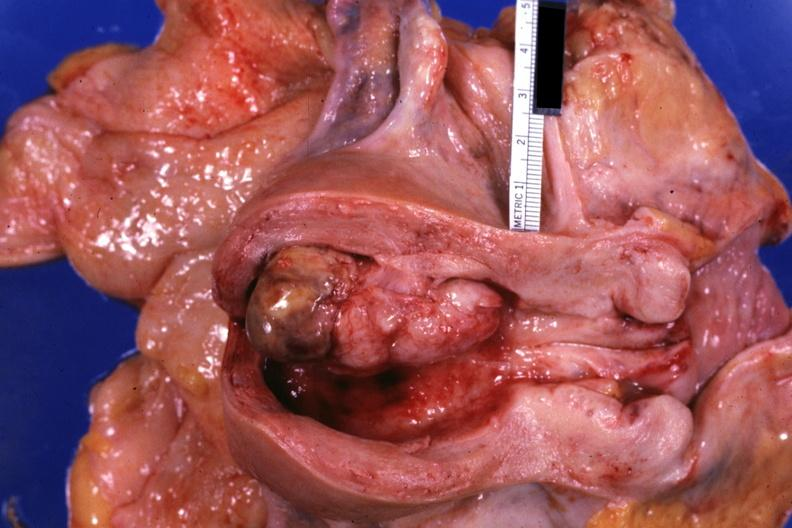where does this part belong to?
Answer the question using a single word or phrase. Female reproductive system 